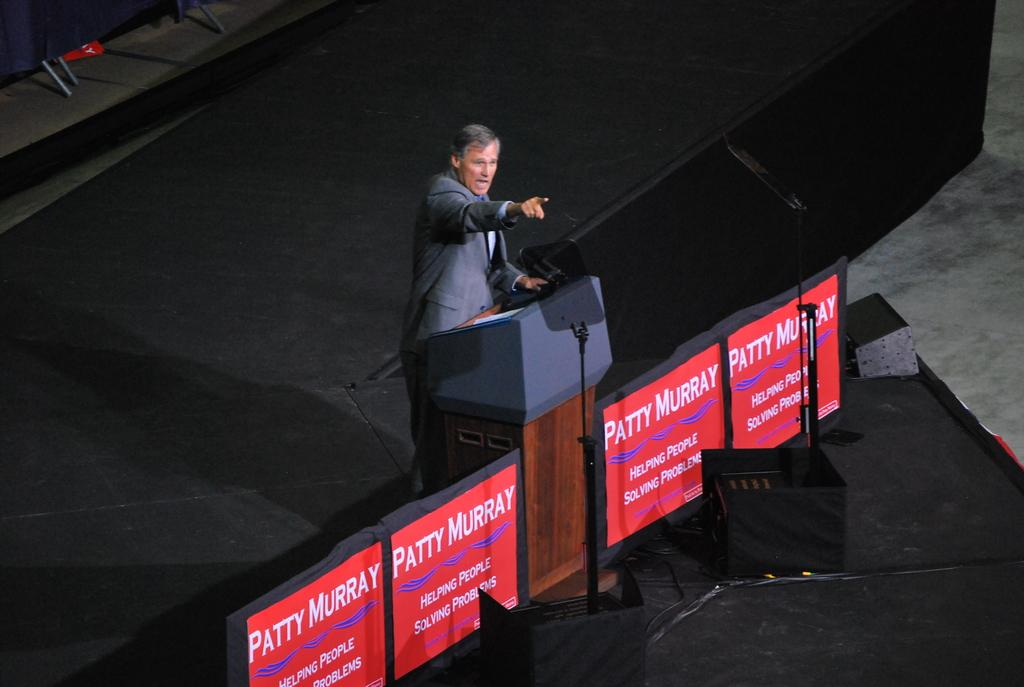What is the person in the image doing? There is a person standing in the image. What object is present in the image that is often used for speeches or presentations? There is a podium in the image. What surface is the person standing on in the image? There is a stage in the image. What device is present in the image that is used for amplifying sound? There is a microphone in the image. What type of objects are present in the image that contain written information? There are posters with text in the image. Can you see a veil covering the person's face in the image? No, there is no veil present in the image. Is the person jumping or performing any acrobatic moves in the image? No, the person is standing still in the image. 